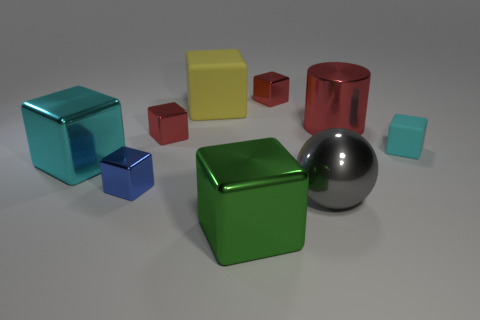How many red cubes must be subtracted to get 1 red cubes? 1 Subtract all tiny red blocks. How many blocks are left? 5 Subtract all blue cubes. How many cubes are left? 6 Subtract all red blocks. Subtract all blue balls. How many blocks are left? 5 Add 1 tiny red metal objects. How many objects exist? 10 Subtract all cubes. How many objects are left? 2 Subtract all big red objects. Subtract all yellow rubber cylinders. How many objects are left? 8 Add 5 matte cubes. How many matte cubes are left? 7 Add 3 red shiny objects. How many red shiny objects exist? 6 Subtract 0 yellow cylinders. How many objects are left? 9 